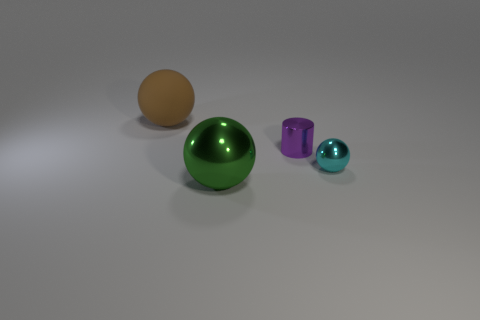Subtract all green cylinders. Subtract all cyan spheres. How many cylinders are left? 1 Subtract all brown blocks. How many brown cylinders are left? 0 Add 1 big blues. How many large objects exist? 0 Subtract all tiny cyan cubes. Subtract all green things. How many objects are left? 3 Add 4 green metallic objects. How many green metallic objects are left? 5 Add 2 big red cylinders. How many big red cylinders exist? 2 Add 3 large gray shiny objects. How many objects exist? 7 Subtract all cyan spheres. How many spheres are left? 2 Subtract all green shiny spheres. How many spheres are left? 2 Subtract 1 cyan spheres. How many objects are left? 3 